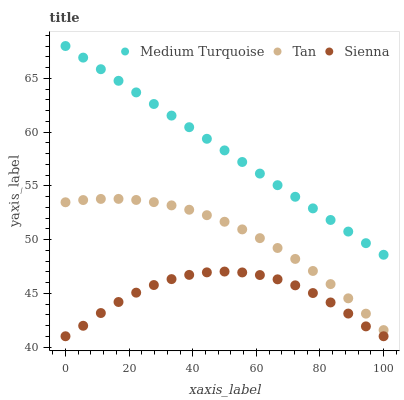Does Sienna have the minimum area under the curve?
Answer yes or no. Yes. Does Medium Turquoise have the maximum area under the curve?
Answer yes or no. Yes. Does Tan have the minimum area under the curve?
Answer yes or no. No. Does Tan have the maximum area under the curve?
Answer yes or no. No. Is Medium Turquoise the smoothest?
Answer yes or no. Yes. Is Sienna the roughest?
Answer yes or no. Yes. Is Tan the smoothest?
Answer yes or no. No. Is Tan the roughest?
Answer yes or no. No. Does Sienna have the lowest value?
Answer yes or no. Yes. Does Tan have the lowest value?
Answer yes or no. No. Does Medium Turquoise have the highest value?
Answer yes or no. Yes. Does Tan have the highest value?
Answer yes or no. No. Is Tan less than Medium Turquoise?
Answer yes or no. Yes. Is Medium Turquoise greater than Sienna?
Answer yes or no. Yes. Does Tan intersect Medium Turquoise?
Answer yes or no. No. 